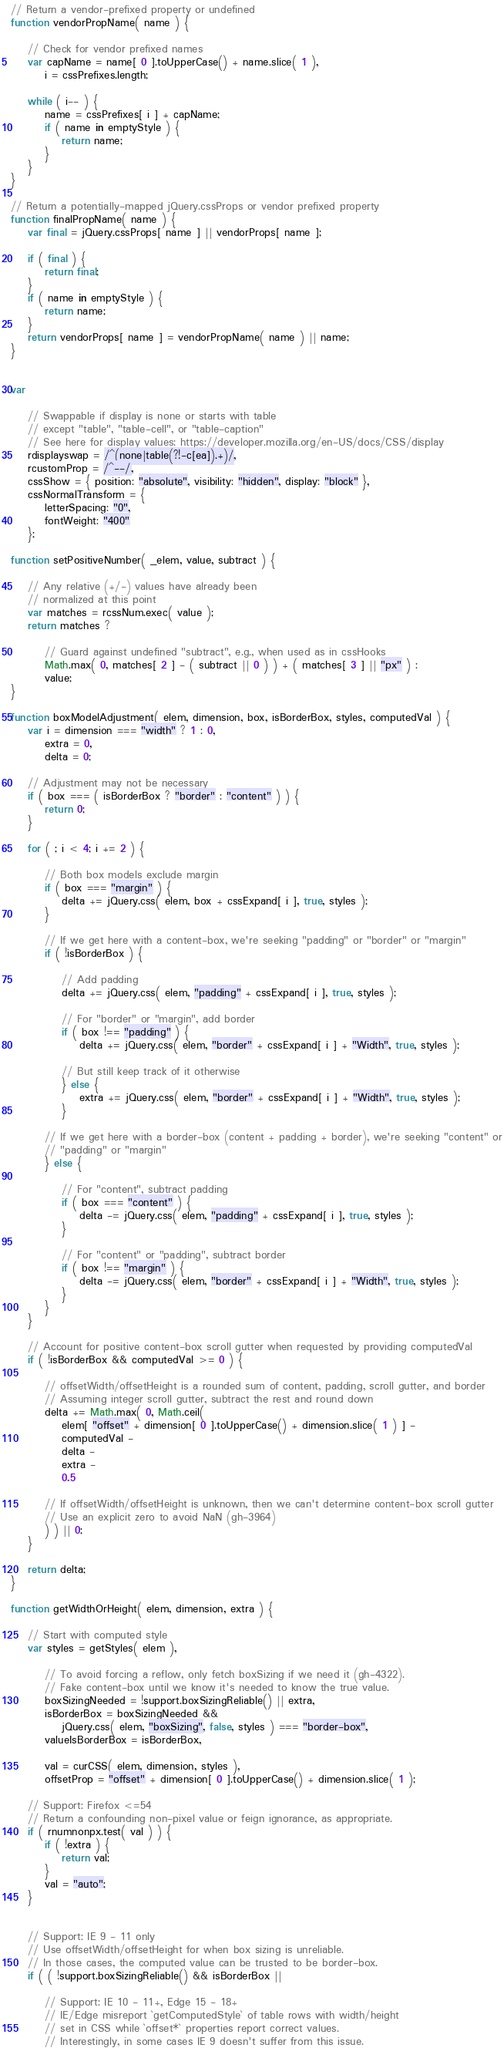<code> <loc_0><loc_0><loc_500><loc_500><_JavaScript_>// Return a vendor-prefixed property or undefined
function vendorPropName( name ) {

	// Check for vendor prefixed names
	var capName = name[ 0 ].toUpperCase() + name.slice( 1 ),
		i = cssPrefixes.length;

	while ( i-- ) {
		name = cssPrefixes[ i ] + capName;
		if ( name in emptyStyle ) {
			return name;
		}
	}
}

// Return a potentially-mapped jQuery.cssProps or vendor prefixed property
function finalPropName( name ) {
	var final = jQuery.cssProps[ name ] || vendorProps[ name ];

	if ( final ) {
		return final;
	}
	if ( name in emptyStyle ) {
		return name;
	}
	return vendorProps[ name ] = vendorPropName( name ) || name;
}


var

	// Swappable if display is none or starts with table
	// except "table", "table-cell", or "table-caption"
	// See here for display values: https://developer.mozilla.org/en-US/docs/CSS/display
	rdisplayswap = /^(none|table(?!-c[ea]).+)/,
	rcustomProp = /^--/,
	cssShow = { position: "absolute", visibility: "hidden", display: "block" },
	cssNormalTransform = {
		letterSpacing: "0",
		fontWeight: "400"
	};

function setPositiveNumber( _elem, value, subtract ) {

	// Any relative (+/-) values have already been
	// normalized at this point
	var matches = rcssNum.exec( value );
	return matches ?

		// Guard against undefined "subtract", e.g., when used as in cssHooks
		Math.max( 0, matches[ 2 ] - ( subtract || 0 ) ) + ( matches[ 3 ] || "px" ) :
		value;
}

function boxModelAdjustment( elem, dimension, box, isBorderBox, styles, computedVal ) {
	var i = dimension === "width" ? 1 : 0,
		extra = 0,
		delta = 0;

	// Adjustment may not be necessary
	if ( box === ( isBorderBox ? "border" : "content" ) ) {
		return 0;
	}

	for ( ; i < 4; i += 2 ) {

		// Both box models exclude margin
		if ( box === "margin" ) {
			delta += jQuery.css( elem, box + cssExpand[ i ], true, styles );
		}

		// If we get here with a content-box, we're seeking "padding" or "border" or "margin"
		if ( !isBorderBox ) {

			// Add padding
			delta += jQuery.css( elem, "padding" + cssExpand[ i ], true, styles );

			// For "border" or "margin", add border
			if ( box !== "padding" ) {
				delta += jQuery.css( elem, "border" + cssExpand[ i ] + "Width", true, styles );

			// But still keep track of it otherwise
			} else {
				extra += jQuery.css( elem, "border" + cssExpand[ i ] + "Width", true, styles );
			}

		// If we get here with a border-box (content + padding + border), we're seeking "content" or
		// "padding" or "margin"
		} else {

			// For "content", subtract padding
			if ( box === "content" ) {
				delta -= jQuery.css( elem, "padding" + cssExpand[ i ], true, styles );
			}

			// For "content" or "padding", subtract border
			if ( box !== "margin" ) {
				delta -= jQuery.css( elem, "border" + cssExpand[ i ] + "Width", true, styles );
			}
		}
	}

	// Account for positive content-box scroll gutter when requested by providing computedVal
	if ( !isBorderBox && computedVal >= 0 ) {

		// offsetWidth/offsetHeight is a rounded sum of content, padding, scroll gutter, and border
		// Assuming integer scroll gutter, subtract the rest and round down
		delta += Math.max( 0, Math.ceil(
			elem[ "offset" + dimension[ 0 ].toUpperCase() + dimension.slice( 1 ) ] -
			computedVal -
			delta -
			extra -
			0.5

		// If offsetWidth/offsetHeight is unknown, then we can't determine content-box scroll gutter
		// Use an explicit zero to avoid NaN (gh-3964)
		) ) || 0;
	}

	return delta;
}

function getWidthOrHeight( elem, dimension, extra ) {

	// Start with computed style
	var styles = getStyles( elem ),

		// To avoid forcing a reflow, only fetch boxSizing if we need it (gh-4322).
		// Fake content-box until we know it's needed to know the true value.
		boxSizingNeeded = !support.boxSizingReliable() || extra,
		isBorderBox = boxSizingNeeded &&
			jQuery.css( elem, "boxSizing", false, styles ) === "border-box",
		valueIsBorderBox = isBorderBox,

		val = curCSS( elem, dimension, styles ),
		offsetProp = "offset" + dimension[ 0 ].toUpperCase() + dimension.slice( 1 );

	// Support: Firefox <=54
	// Return a confounding non-pixel value or feign ignorance, as appropriate.
	if ( rnumnonpx.test( val ) ) {
		if ( !extra ) {
			return val;
		}
		val = "auto";
	}


	// Support: IE 9 - 11 only
	// Use offsetWidth/offsetHeight for when box sizing is unreliable.
	// In those cases, the computed value can be trusted to be border-box.
	if ( ( !support.boxSizingReliable() && isBorderBox ||

		// Support: IE 10 - 11+, Edge 15 - 18+
		// IE/Edge misreport `getComputedStyle` of table rows with width/height
		// set in CSS while `offset*` properties report correct values.
		// Interestingly, in some cases IE 9 doesn't suffer from this issue.</code> 